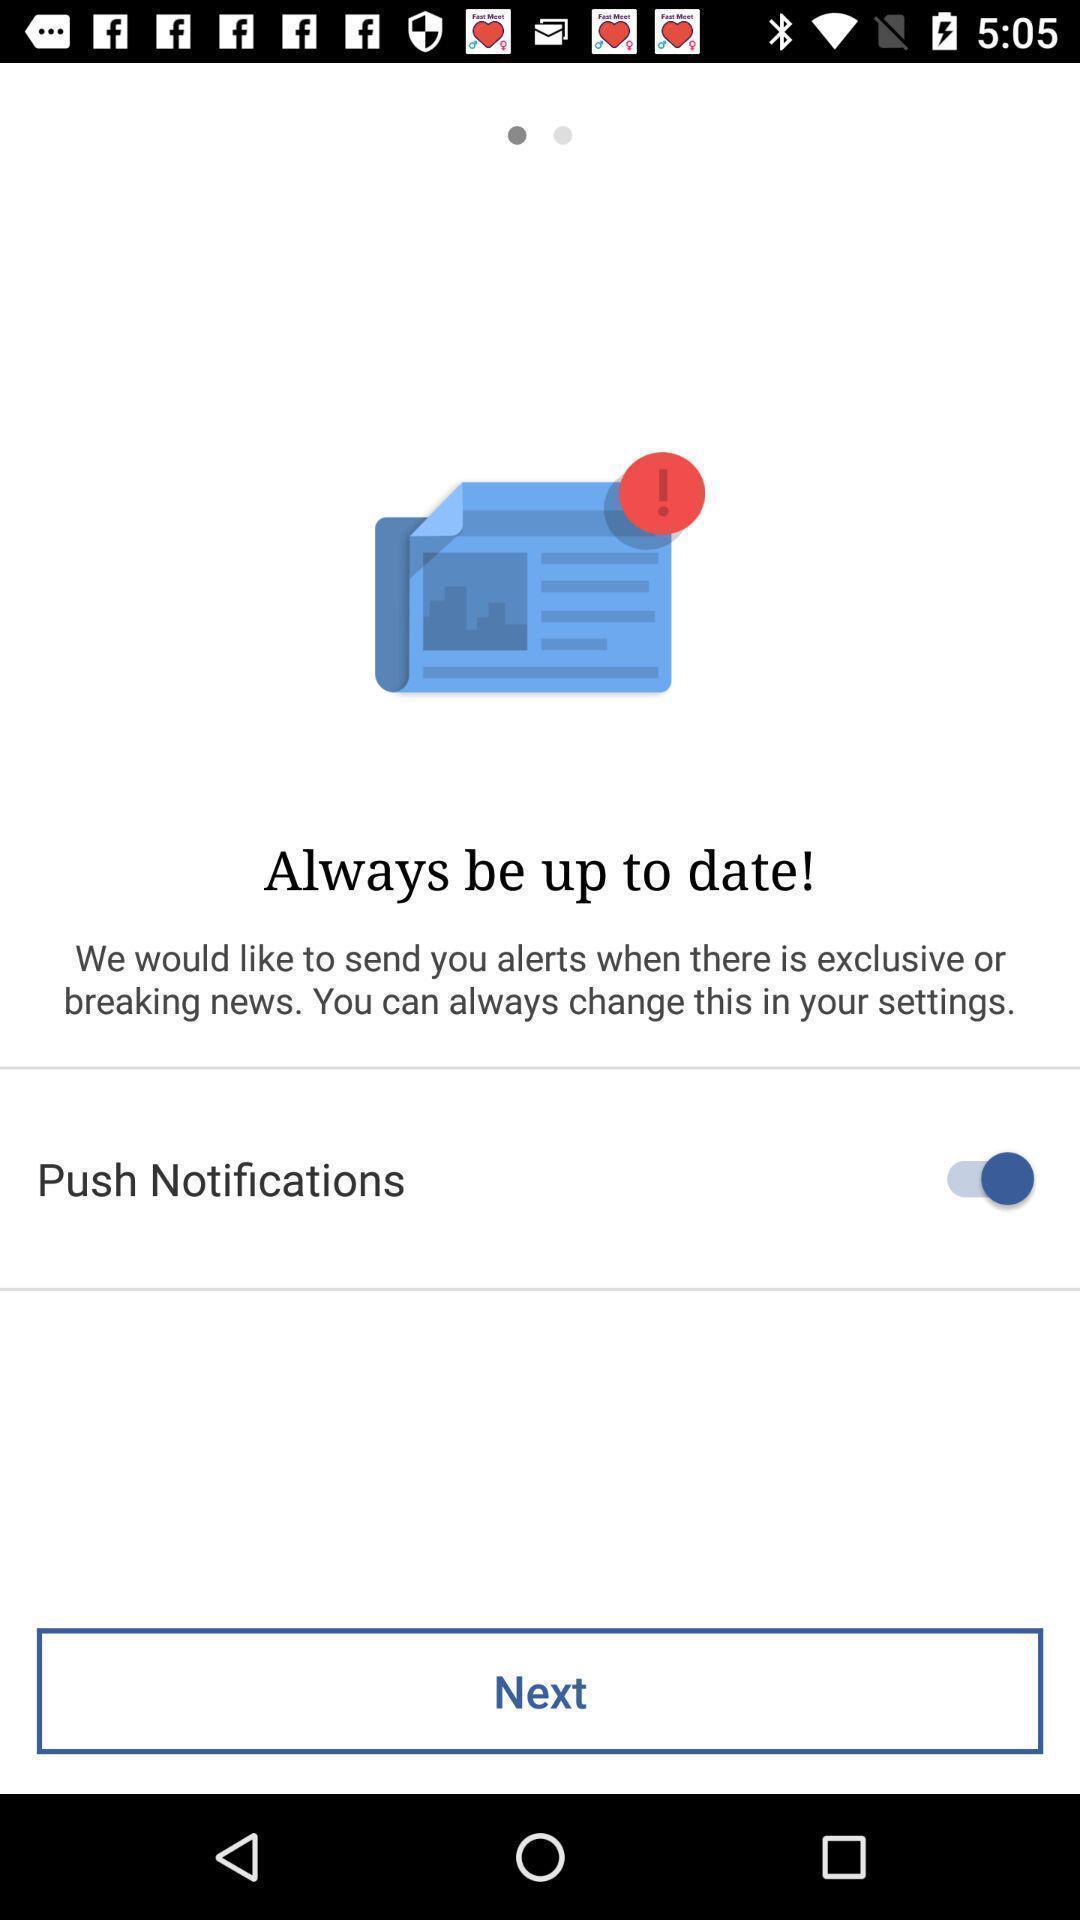What can you discern from this picture? Screen page with notifications option. 